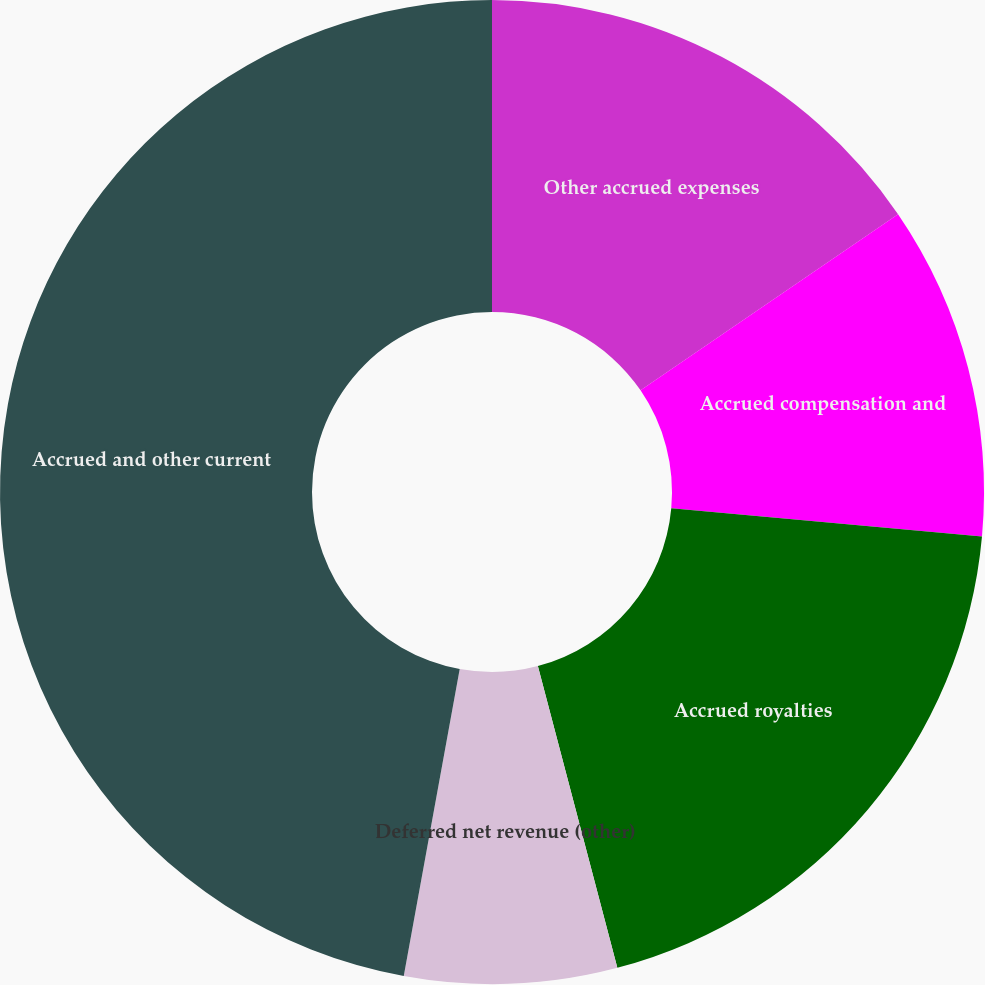<chart> <loc_0><loc_0><loc_500><loc_500><pie_chart><fcel>Other accrued expenses<fcel>Accrued compensation and<fcel>Accrued royalties<fcel>Deferred net revenue (other)<fcel>Accrued and other current<nl><fcel>15.45%<fcel>10.99%<fcel>19.46%<fcel>6.97%<fcel>47.13%<nl></chart> 